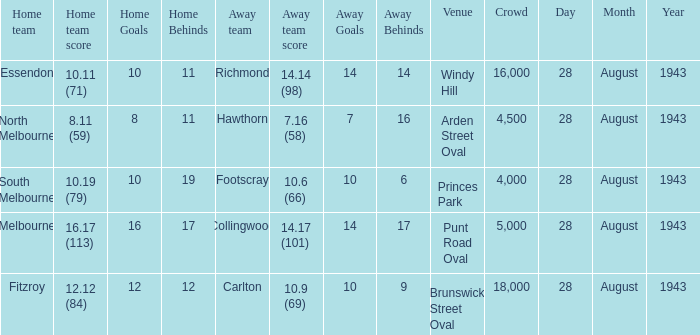What game showed a home team score of 8.11 (59)? 28 August 1943. 